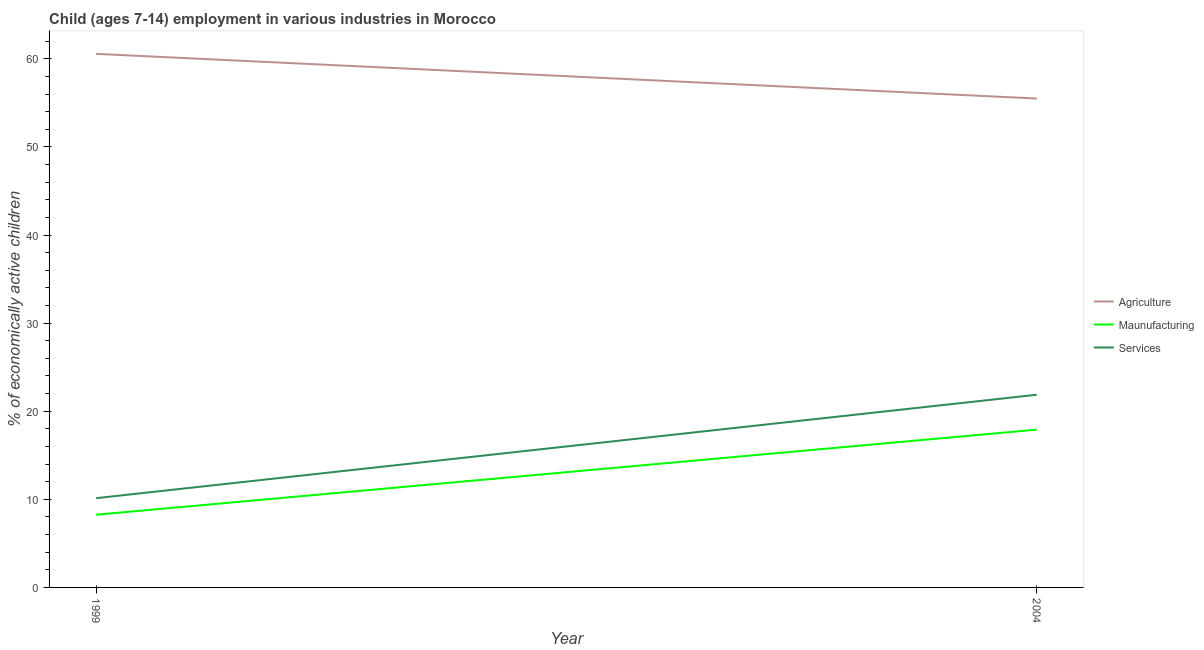Is the number of lines equal to the number of legend labels?
Your answer should be very brief. Yes. What is the percentage of economically active children in services in 1999?
Provide a short and direct response. 10.13. Across all years, what is the maximum percentage of economically active children in manufacturing?
Make the answer very short. 17.91. Across all years, what is the minimum percentage of economically active children in manufacturing?
Ensure brevity in your answer.  8.25. In which year was the percentage of economically active children in manufacturing maximum?
Keep it short and to the point. 2004. In which year was the percentage of economically active children in agriculture minimum?
Provide a succinct answer. 2004. What is the total percentage of economically active children in manufacturing in the graph?
Your answer should be very brief. 26.16. What is the difference between the percentage of economically active children in agriculture in 1999 and that in 2004?
Ensure brevity in your answer.  5.07. What is the difference between the percentage of economically active children in manufacturing in 1999 and the percentage of economically active children in services in 2004?
Keep it short and to the point. -13.62. What is the average percentage of economically active children in manufacturing per year?
Make the answer very short. 13.08. In the year 1999, what is the difference between the percentage of economically active children in agriculture and percentage of economically active children in manufacturing?
Make the answer very short. 52.31. What is the ratio of the percentage of economically active children in services in 1999 to that in 2004?
Provide a short and direct response. 0.46. Is the percentage of economically active children in manufacturing in 1999 less than that in 2004?
Offer a terse response. Yes. Is it the case that in every year, the sum of the percentage of economically active children in agriculture and percentage of economically active children in manufacturing is greater than the percentage of economically active children in services?
Your response must be concise. Yes. Does the percentage of economically active children in manufacturing monotonically increase over the years?
Offer a terse response. Yes. Is the percentage of economically active children in agriculture strictly greater than the percentage of economically active children in manufacturing over the years?
Provide a short and direct response. Yes. Does the graph contain any zero values?
Your answer should be very brief. No. What is the title of the graph?
Keep it short and to the point. Child (ages 7-14) employment in various industries in Morocco. What is the label or title of the Y-axis?
Make the answer very short. % of economically active children. What is the % of economically active children in Agriculture in 1999?
Your answer should be compact. 60.56. What is the % of economically active children in Maunufacturing in 1999?
Keep it short and to the point. 8.25. What is the % of economically active children in Services in 1999?
Provide a short and direct response. 10.13. What is the % of economically active children in Agriculture in 2004?
Give a very brief answer. 55.49. What is the % of economically active children in Maunufacturing in 2004?
Your response must be concise. 17.91. What is the % of economically active children of Services in 2004?
Make the answer very short. 21.87. Across all years, what is the maximum % of economically active children of Agriculture?
Give a very brief answer. 60.56. Across all years, what is the maximum % of economically active children of Maunufacturing?
Offer a terse response. 17.91. Across all years, what is the maximum % of economically active children of Services?
Keep it short and to the point. 21.87. Across all years, what is the minimum % of economically active children of Agriculture?
Keep it short and to the point. 55.49. Across all years, what is the minimum % of economically active children in Maunufacturing?
Offer a terse response. 8.25. Across all years, what is the minimum % of economically active children in Services?
Offer a terse response. 10.13. What is the total % of economically active children of Agriculture in the graph?
Keep it short and to the point. 116.05. What is the total % of economically active children in Maunufacturing in the graph?
Your response must be concise. 26.16. What is the total % of economically active children in Services in the graph?
Ensure brevity in your answer.  32. What is the difference between the % of economically active children in Agriculture in 1999 and that in 2004?
Offer a terse response. 5.07. What is the difference between the % of economically active children of Maunufacturing in 1999 and that in 2004?
Provide a succinct answer. -9.66. What is the difference between the % of economically active children of Services in 1999 and that in 2004?
Provide a succinct answer. -11.74. What is the difference between the % of economically active children of Agriculture in 1999 and the % of economically active children of Maunufacturing in 2004?
Your answer should be compact. 42.65. What is the difference between the % of economically active children of Agriculture in 1999 and the % of economically active children of Services in 2004?
Make the answer very short. 38.69. What is the difference between the % of economically active children in Maunufacturing in 1999 and the % of economically active children in Services in 2004?
Your answer should be very brief. -13.62. What is the average % of economically active children in Agriculture per year?
Make the answer very short. 58.02. What is the average % of economically active children in Maunufacturing per year?
Your answer should be compact. 13.08. What is the average % of economically active children of Services per year?
Ensure brevity in your answer.  16. In the year 1999, what is the difference between the % of economically active children in Agriculture and % of economically active children in Maunufacturing?
Offer a terse response. 52.31. In the year 1999, what is the difference between the % of economically active children in Agriculture and % of economically active children in Services?
Offer a terse response. 50.43. In the year 1999, what is the difference between the % of economically active children of Maunufacturing and % of economically active children of Services?
Keep it short and to the point. -1.88. In the year 2004, what is the difference between the % of economically active children of Agriculture and % of economically active children of Maunufacturing?
Make the answer very short. 37.58. In the year 2004, what is the difference between the % of economically active children in Agriculture and % of economically active children in Services?
Keep it short and to the point. 33.62. In the year 2004, what is the difference between the % of economically active children of Maunufacturing and % of economically active children of Services?
Your answer should be very brief. -3.96. What is the ratio of the % of economically active children of Agriculture in 1999 to that in 2004?
Offer a terse response. 1.09. What is the ratio of the % of economically active children of Maunufacturing in 1999 to that in 2004?
Provide a succinct answer. 0.46. What is the ratio of the % of economically active children in Services in 1999 to that in 2004?
Provide a short and direct response. 0.46. What is the difference between the highest and the second highest % of economically active children in Agriculture?
Ensure brevity in your answer.  5.07. What is the difference between the highest and the second highest % of economically active children of Maunufacturing?
Provide a succinct answer. 9.66. What is the difference between the highest and the second highest % of economically active children of Services?
Your answer should be compact. 11.74. What is the difference between the highest and the lowest % of economically active children in Agriculture?
Your answer should be very brief. 5.07. What is the difference between the highest and the lowest % of economically active children of Maunufacturing?
Provide a short and direct response. 9.66. What is the difference between the highest and the lowest % of economically active children of Services?
Your answer should be very brief. 11.74. 